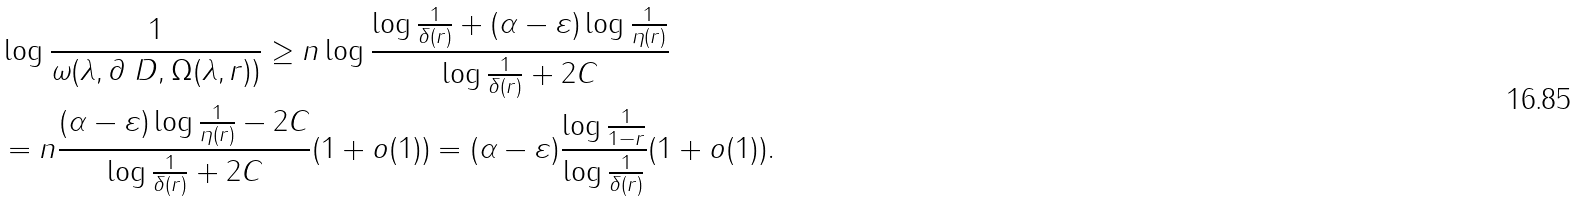Convert formula to latex. <formula><loc_0><loc_0><loc_500><loc_500>& \log \frac { 1 } { \omega ( \lambda , \partial \ D , \Omega ( \lambda , r ) ) } \geq n \log \frac { \log \frac { 1 } { \delta ( r ) } + ( \alpha - \varepsilon ) \log \frac { 1 } { \eta ( r ) } } { \log \frac { 1 } { \delta ( r ) } + 2 C } \\ & = n \frac { ( \alpha - \varepsilon ) \log \frac { 1 } { \eta ( r ) } - 2 C } { \log \frac { 1 } { \delta ( r ) } + 2 C } ( 1 + o ( 1 ) ) = ( \alpha - \varepsilon ) \frac { \log \frac { 1 } { 1 - r } } { \log \frac { 1 } { \delta ( r ) } } ( 1 + o ( 1 ) ) .</formula> 